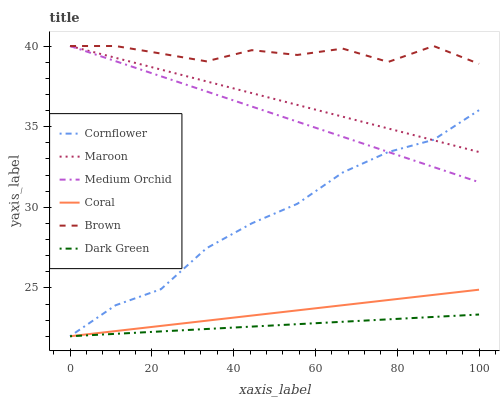Does Dark Green have the minimum area under the curve?
Answer yes or no. Yes. Does Brown have the maximum area under the curve?
Answer yes or no. Yes. Does Coral have the minimum area under the curve?
Answer yes or no. No. Does Coral have the maximum area under the curve?
Answer yes or no. No. Is Dark Green the smoothest?
Answer yes or no. Yes. Is Brown the roughest?
Answer yes or no. Yes. Is Coral the smoothest?
Answer yes or no. No. Is Coral the roughest?
Answer yes or no. No. Does Cornflower have the lowest value?
Answer yes or no. Yes. Does Brown have the lowest value?
Answer yes or no. No. Does Maroon have the highest value?
Answer yes or no. Yes. Does Coral have the highest value?
Answer yes or no. No. Is Coral less than Medium Orchid?
Answer yes or no. Yes. Is Brown greater than Coral?
Answer yes or no. Yes. Does Medium Orchid intersect Cornflower?
Answer yes or no. Yes. Is Medium Orchid less than Cornflower?
Answer yes or no. No. Is Medium Orchid greater than Cornflower?
Answer yes or no. No. Does Coral intersect Medium Orchid?
Answer yes or no. No. 